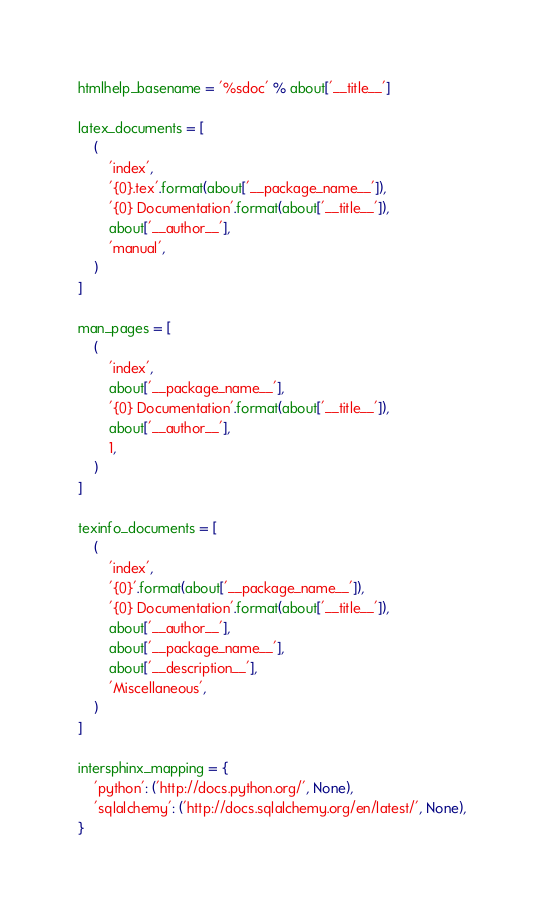Convert code to text. <code><loc_0><loc_0><loc_500><loc_500><_Python_>
htmlhelp_basename = '%sdoc' % about['__title__']

latex_documents = [
    (
        'index',
        '{0}.tex'.format(about['__package_name__']),
        '{0} Documentation'.format(about['__title__']),
        about['__author__'],
        'manual',
    )
]

man_pages = [
    (
        'index',
        about['__package_name__'],
        '{0} Documentation'.format(about['__title__']),
        about['__author__'],
        1,
    )
]

texinfo_documents = [
    (
        'index',
        '{0}'.format(about['__package_name__']),
        '{0} Documentation'.format(about['__title__']),
        about['__author__'],
        about['__package_name__'],
        about['__description__'],
        'Miscellaneous',
    )
]

intersphinx_mapping = {
    'python': ('http://docs.python.org/', None),
    'sqlalchemy': ('http://docs.sqlalchemy.org/en/latest/', None),
}
</code> 